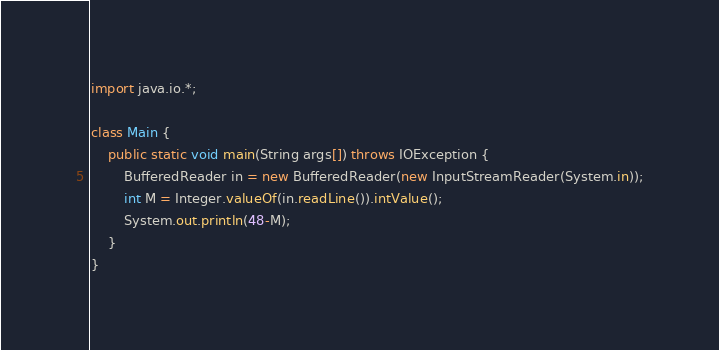Convert code to text. <code><loc_0><loc_0><loc_500><loc_500><_Java_>import java.io.*;

class Main {
    public static void main(String args[]) throws IOException {
        BufferedReader in = new BufferedReader(new InputStreamReader(System.in));
        int M = Integer.valueOf(in.readLine()).intValue();
        System.out.println(48-M);
    }
}</code> 